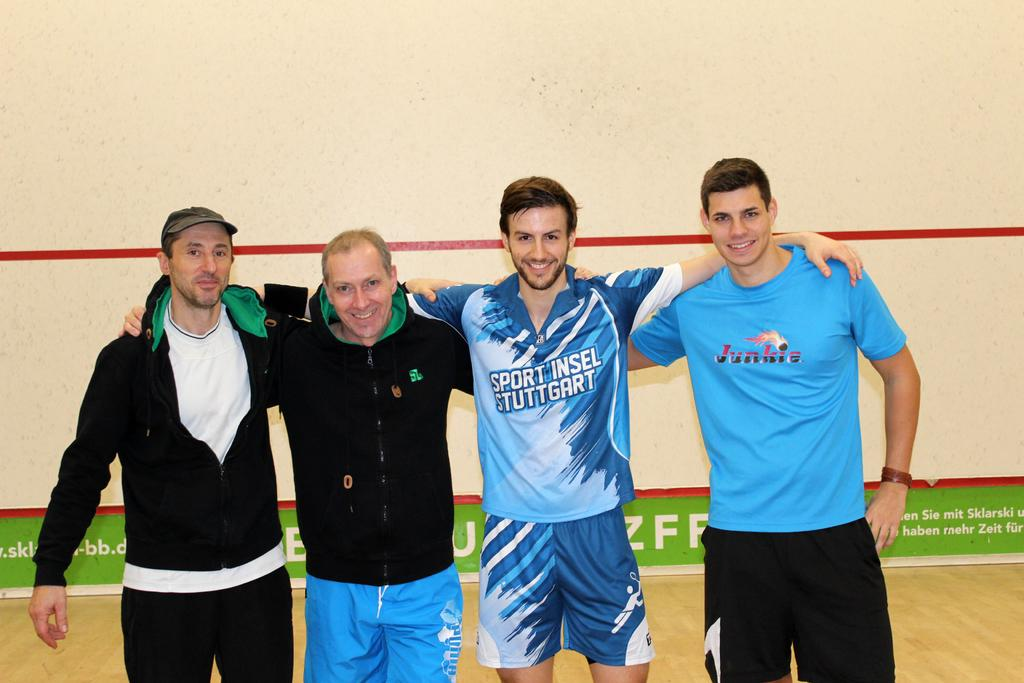<image>
Give a short and clear explanation of the subsequent image. One of the men in the picture has a t shirt with junkie written on it 